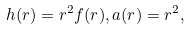Convert formula to latex. <formula><loc_0><loc_0><loc_500><loc_500>h ( r ) = r ^ { 2 } f ( r ) , a ( r ) = r ^ { 2 } ,</formula> 